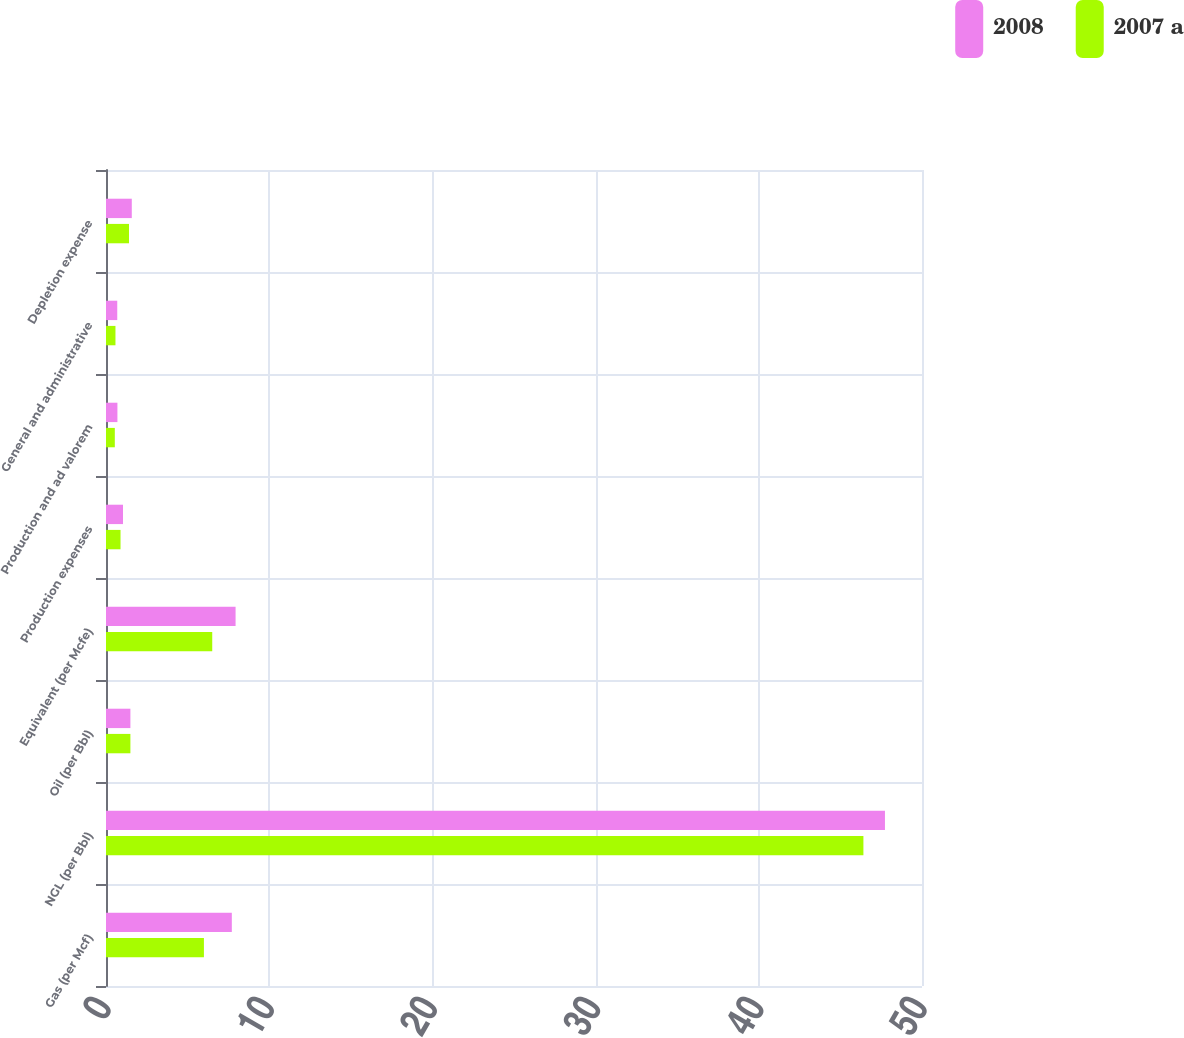<chart> <loc_0><loc_0><loc_500><loc_500><stacked_bar_chart><ecel><fcel>Gas (per Mcf)<fcel>NGL (per Bbl)<fcel>Oil (per Bbl)<fcel>Equivalent (per Mcfe)<fcel>Production expenses<fcel>Production and ad valorem<fcel>General and administrative<fcel>Depletion expense<nl><fcel>2008<fcel>7.71<fcel>47.73<fcel>1.495<fcel>7.94<fcel>1.04<fcel>0.7<fcel>0.69<fcel>1.58<nl><fcel>2007 a<fcel>6<fcel>46.41<fcel>1.495<fcel>6.51<fcel>0.89<fcel>0.54<fcel>0.58<fcel>1.41<nl></chart> 